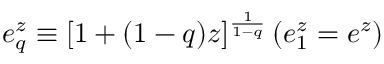Convert formula to latex. <formula><loc_0><loc_0><loc_500><loc_500>e _ { q } ^ { z } \equiv [ 1 + ( 1 - q ) z ] ^ { \frac { 1 } { 1 - q } } \, ( e _ { 1 } ^ { z } = e ^ { z } )</formula> 